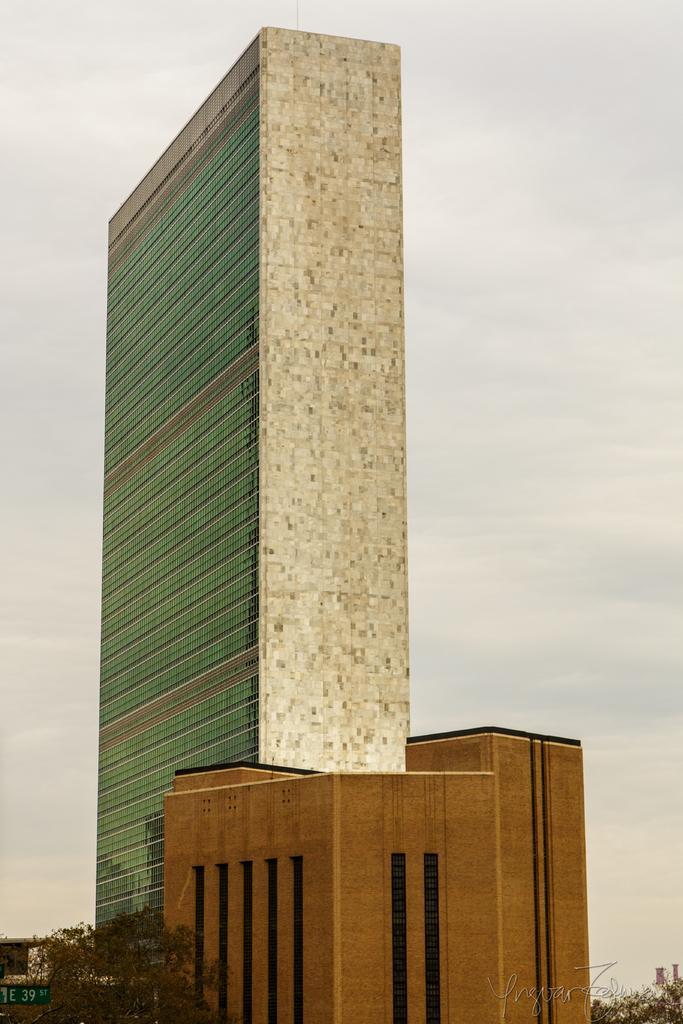Please provide a concise description of this image. In this picture there are buildings and trees. At the bottom left there is a board. At the top there is sky. 